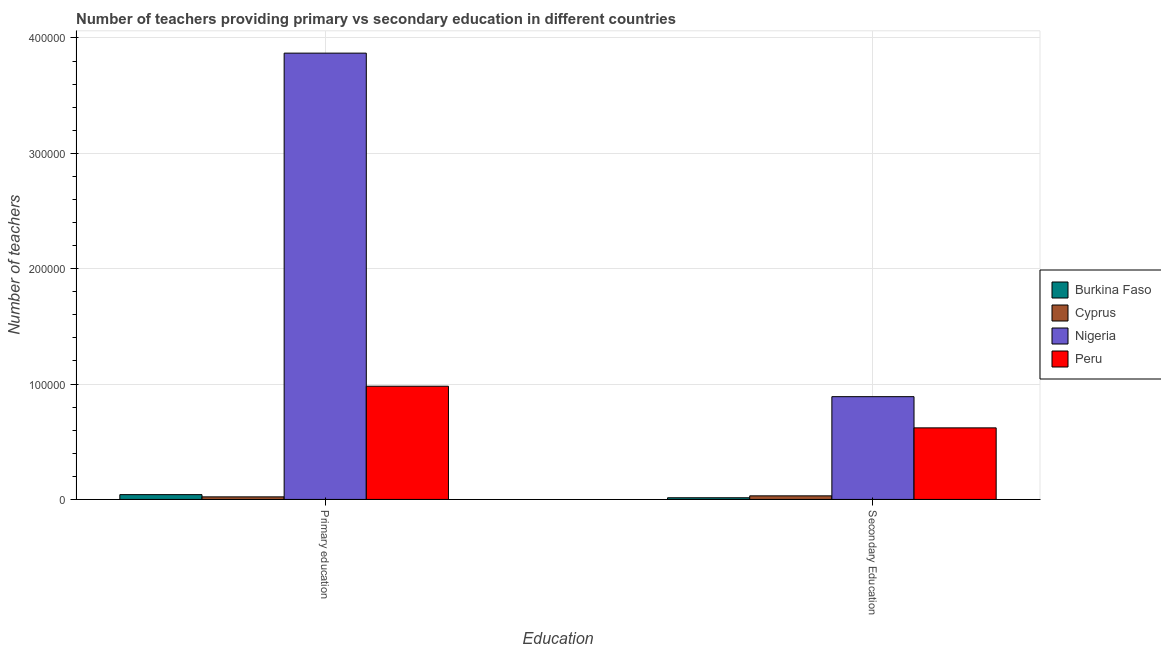How many groups of bars are there?
Provide a short and direct response. 2. Are the number of bars per tick equal to the number of legend labels?
Provide a short and direct response. Yes. What is the label of the 2nd group of bars from the left?
Provide a short and direct response. Secondary Education. What is the number of secondary teachers in Burkina Faso?
Provide a short and direct response. 1451. Across all countries, what is the maximum number of primary teachers?
Make the answer very short. 3.87e+05. Across all countries, what is the minimum number of primary teachers?
Provide a succinct answer. 2221. In which country was the number of primary teachers maximum?
Your answer should be compact. Nigeria. In which country was the number of secondary teachers minimum?
Provide a short and direct response. Burkina Faso. What is the total number of secondary teachers in the graph?
Offer a very short reply. 1.56e+05. What is the difference between the number of secondary teachers in Burkina Faso and that in Peru?
Your answer should be compact. -6.06e+04. What is the difference between the number of secondary teachers in Burkina Faso and the number of primary teachers in Cyprus?
Offer a very short reply. -770. What is the average number of secondary teachers per country?
Offer a very short reply. 3.89e+04. What is the difference between the number of secondary teachers and number of primary teachers in Cyprus?
Provide a short and direct response. 872. In how many countries, is the number of secondary teachers greater than 180000 ?
Offer a terse response. 0. What is the ratio of the number of primary teachers in Burkina Faso to that in Peru?
Ensure brevity in your answer.  0.04. Is the number of secondary teachers in Cyprus less than that in Peru?
Make the answer very short. Yes. In how many countries, is the number of secondary teachers greater than the average number of secondary teachers taken over all countries?
Your answer should be compact. 2. What does the 3rd bar from the left in Secondary Education represents?
Offer a terse response. Nigeria. What does the 2nd bar from the right in Primary education represents?
Your answer should be very brief. Nigeria. Are all the bars in the graph horizontal?
Ensure brevity in your answer.  No. How many countries are there in the graph?
Offer a terse response. 4. Are the values on the major ticks of Y-axis written in scientific E-notation?
Provide a succinct answer. No. Does the graph contain any zero values?
Your response must be concise. No. Where does the legend appear in the graph?
Offer a terse response. Center right. How many legend labels are there?
Make the answer very short. 4. What is the title of the graph?
Your answer should be very brief. Number of teachers providing primary vs secondary education in different countries. What is the label or title of the X-axis?
Make the answer very short. Education. What is the label or title of the Y-axis?
Ensure brevity in your answer.  Number of teachers. What is the Number of teachers in Burkina Faso in Primary education?
Offer a terse response. 4153. What is the Number of teachers of Cyprus in Primary education?
Make the answer very short. 2221. What is the Number of teachers of Nigeria in Primary education?
Provide a short and direct response. 3.87e+05. What is the Number of teachers in Peru in Primary education?
Offer a terse response. 9.81e+04. What is the Number of teachers in Burkina Faso in Secondary Education?
Ensure brevity in your answer.  1451. What is the Number of teachers in Cyprus in Secondary Education?
Your answer should be very brief. 3093. What is the Number of teachers in Nigeria in Secondary Education?
Offer a very short reply. 8.91e+04. What is the Number of teachers of Peru in Secondary Education?
Keep it short and to the point. 6.20e+04. Across all Education, what is the maximum Number of teachers of Burkina Faso?
Your response must be concise. 4153. Across all Education, what is the maximum Number of teachers in Cyprus?
Offer a terse response. 3093. Across all Education, what is the maximum Number of teachers of Nigeria?
Your answer should be compact. 3.87e+05. Across all Education, what is the maximum Number of teachers in Peru?
Your response must be concise. 9.81e+04. Across all Education, what is the minimum Number of teachers in Burkina Faso?
Offer a very short reply. 1451. Across all Education, what is the minimum Number of teachers in Cyprus?
Make the answer very short. 2221. Across all Education, what is the minimum Number of teachers in Nigeria?
Make the answer very short. 8.91e+04. Across all Education, what is the minimum Number of teachers in Peru?
Keep it short and to the point. 6.20e+04. What is the total Number of teachers in Burkina Faso in the graph?
Ensure brevity in your answer.  5604. What is the total Number of teachers in Cyprus in the graph?
Provide a short and direct response. 5314. What is the total Number of teachers of Nigeria in the graph?
Your response must be concise. 4.76e+05. What is the total Number of teachers in Peru in the graph?
Give a very brief answer. 1.60e+05. What is the difference between the Number of teachers of Burkina Faso in Primary education and that in Secondary Education?
Ensure brevity in your answer.  2702. What is the difference between the Number of teachers of Cyprus in Primary education and that in Secondary Education?
Your response must be concise. -872. What is the difference between the Number of teachers of Nigeria in Primary education and that in Secondary Education?
Offer a very short reply. 2.98e+05. What is the difference between the Number of teachers of Peru in Primary education and that in Secondary Education?
Your answer should be very brief. 3.61e+04. What is the difference between the Number of teachers of Burkina Faso in Primary education and the Number of teachers of Cyprus in Secondary Education?
Make the answer very short. 1060. What is the difference between the Number of teachers in Burkina Faso in Primary education and the Number of teachers in Nigeria in Secondary Education?
Give a very brief answer. -8.49e+04. What is the difference between the Number of teachers in Burkina Faso in Primary education and the Number of teachers in Peru in Secondary Education?
Offer a terse response. -5.79e+04. What is the difference between the Number of teachers in Cyprus in Primary education and the Number of teachers in Nigeria in Secondary Education?
Your answer should be very brief. -8.69e+04. What is the difference between the Number of teachers of Cyprus in Primary education and the Number of teachers of Peru in Secondary Education?
Give a very brief answer. -5.98e+04. What is the difference between the Number of teachers in Nigeria in Primary education and the Number of teachers in Peru in Secondary Education?
Make the answer very short. 3.25e+05. What is the average Number of teachers in Burkina Faso per Education?
Make the answer very short. 2802. What is the average Number of teachers of Cyprus per Education?
Make the answer very short. 2657. What is the average Number of teachers of Nigeria per Education?
Provide a succinct answer. 2.38e+05. What is the average Number of teachers in Peru per Education?
Make the answer very short. 8.01e+04. What is the difference between the Number of teachers in Burkina Faso and Number of teachers in Cyprus in Primary education?
Your answer should be very brief. 1932. What is the difference between the Number of teachers in Burkina Faso and Number of teachers in Nigeria in Primary education?
Make the answer very short. -3.83e+05. What is the difference between the Number of teachers in Burkina Faso and Number of teachers in Peru in Primary education?
Keep it short and to the point. -9.40e+04. What is the difference between the Number of teachers in Cyprus and Number of teachers in Nigeria in Primary education?
Your answer should be compact. -3.85e+05. What is the difference between the Number of teachers in Cyprus and Number of teachers in Peru in Primary education?
Provide a succinct answer. -9.59e+04. What is the difference between the Number of teachers in Nigeria and Number of teachers in Peru in Primary education?
Keep it short and to the point. 2.89e+05. What is the difference between the Number of teachers of Burkina Faso and Number of teachers of Cyprus in Secondary Education?
Offer a very short reply. -1642. What is the difference between the Number of teachers in Burkina Faso and Number of teachers in Nigeria in Secondary Education?
Make the answer very short. -8.76e+04. What is the difference between the Number of teachers of Burkina Faso and Number of teachers of Peru in Secondary Education?
Offer a terse response. -6.06e+04. What is the difference between the Number of teachers of Cyprus and Number of teachers of Nigeria in Secondary Education?
Offer a terse response. -8.60e+04. What is the difference between the Number of teachers in Cyprus and Number of teachers in Peru in Secondary Education?
Offer a very short reply. -5.89e+04. What is the difference between the Number of teachers of Nigeria and Number of teachers of Peru in Secondary Education?
Provide a short and direct response. 2.71e+04. What is the ratio of the Number of teachers in Burkina Faso in Primary education to that in Secondary Education?
Make the answer very short. 2.86. What is the ratio of the Number of teachers in Cyprus in Primary education to that in Secondary Education?
Give a very brief answer. 0.72. What is the ratio of the Number of teachers of Nigeria in Primary education to that in Secondary Education?
Provide a succinct answer. 4.34. What is the ratio of the Number of teachers of Peru in Primary education to that in Secondary Education?
Offer a very short reply. 1.58. What is the difference between the highest and the second highest Number of teachers of Burkina Faso?
Your answer should be very brief. 2702. What is the difference between the highest and the second highest Number of teachers in Cyprus?
Provide a short and direct response. 872. What is the difference between the highest and the second highest Number of teachers of Nigeria?
Your answer should be very brief. 2.98e+05. What is the difference between the highest and the second highest Number of teachers of Peru?
Provide a short and direct response. 3.61e+04. What is the difference between the highest and the lowest Number of teachers in Burkina Faso?
Keep it short and to the point. 2702. What is the difference between the highest and the lowest Number of teachers in Cyprus?
Make the answer very short. 872. What is the difference between the highest and the lowest Number of teachers in Nigeria?
Your response must be concise. 2.98e+05. What is the difference between the highest and the lowest Number of teachers in Peru?
Your answer should be very brief. 3.61e+04. 